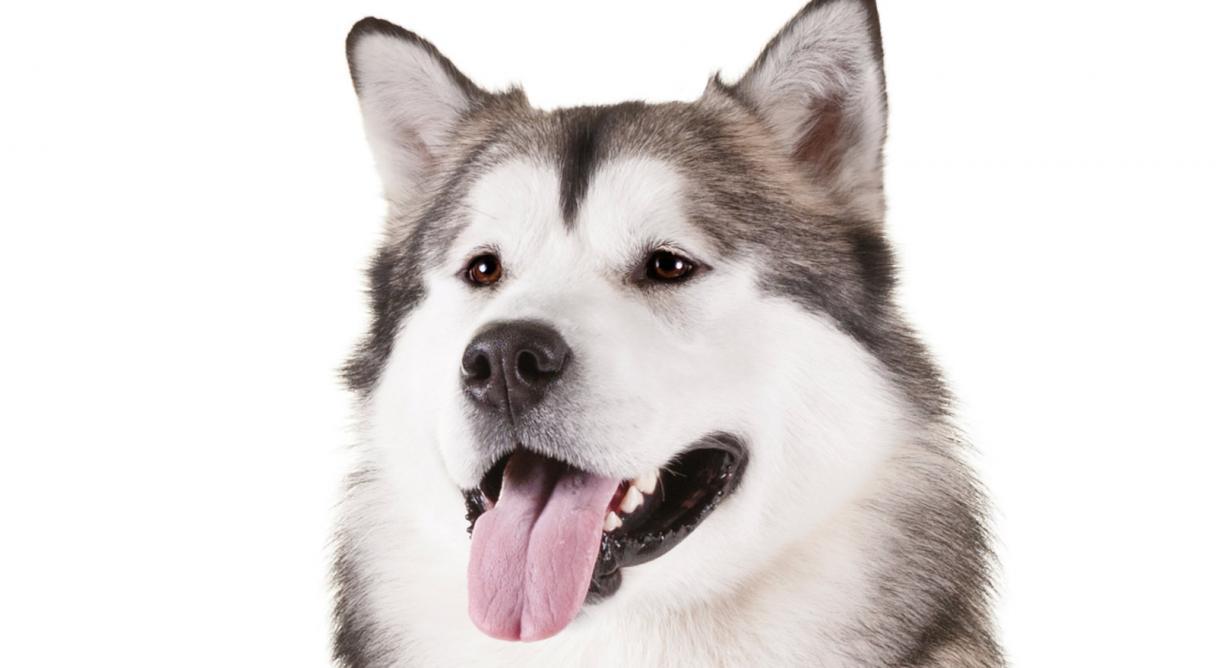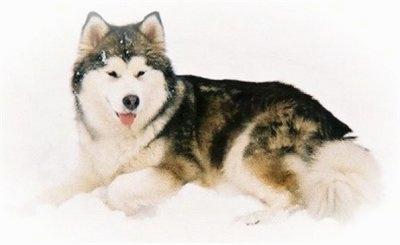The first image is the image on the left, the second image is the image on the right. For the images shown, is this caption "All dogs are standing, and each image contains a dog with an upturned, curled tail." true? Answer yes or no. No. The first image is the image on the left, the second image is the image on the right. Considering the images on both sides, is "There are only two dogs, and both of them are showing their tongues." valid? Answer yes or no. Yes. 